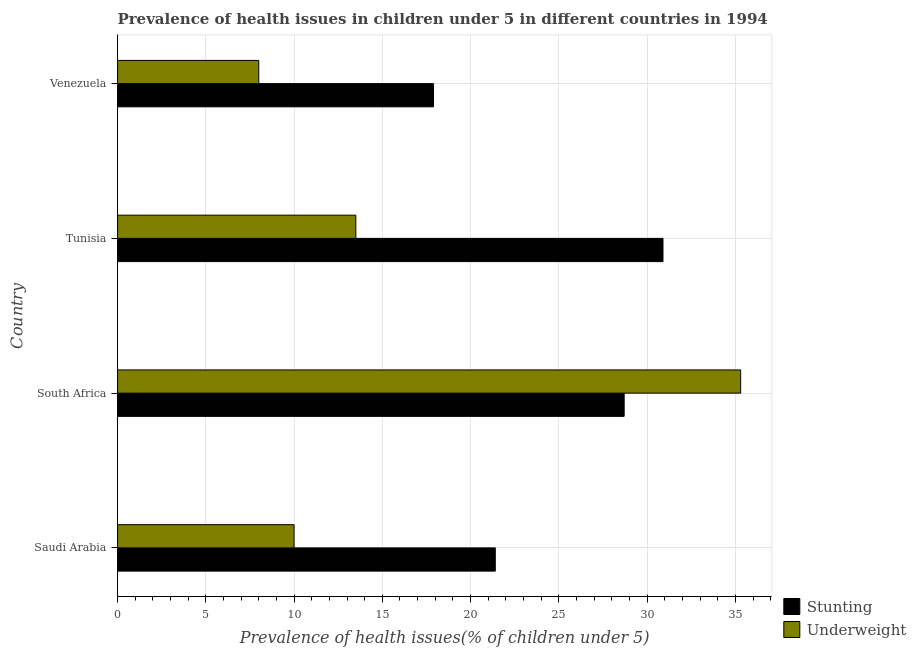How many different coloured bars are there?
Your answer should be compact. 2. Are the number of bars on each tick of the Y-axis equal?
Offer a terse response. Yes. How many bars are there on the 4th tick from the top?
Offer a terse response. 2. How many bars are there on the 4th tick from the bottom?
Your response must be concise. 2. What is the label of the 3rd group of bars from the top?
Keep it short and to the point. South Africa. In how many cases, is the number of bars for a given country not equal to the number of legend labels?
Keep it short and to the point. 0. What is the percentage of underweight children in South Africa?
Your response must be concise. 35.3. Across all countries, what is the maximum percentage of underweight children?
Make the answer very short. 35.3. In which country was the percentage of underweight children maximum?
Give a very brief answer. South Africa. In which country was the percentage of underweight children minimum?
Make the answer very short. Venezuela. What is the total percentage of underweight children in the graph?
Provide a short and direct response. 66.8. What is the difference between the percentage of stunted children in Saudi Arabia and that in Tunisia?
Your answer should be very brief. -9.5. What is the difference between the percentage of stunted children in Venezuela and the percentage of underweight children in Saudi Arabia?
Provide a short and direct response. 7.9. What is the ratio of the percentage of underweight children in South Africa to that in Venezuela?
Provide a short and direct response. 4.41. Is the difference between the percentage of underweight children in South Africa and Tunisia greater than the difference between the percentage of stunted children in South Africa and Tunisia?
Keep it short and to the point. Yes. What is the difference between the highest and the second highest percentage of underweight children?
Offer a very short reply. 21.8. What is the difference between the highest and the lowest percentage of underweight children?
Your answer should be compact. 27.3. In how many countries, is the percentage of stunted children greater than the average percentage of stunted children taken over all countries?
Your response must be concise. 2. Is the sum of the percentage of underweight children in Tunisia and Venezuela greater than the maximum percentage of stunted children across all countries?
Make the answer very short. No. What does the 2nd bar from the top in South Africa represents?
Make the answer very short. Stunting. What does the 2nd bar from the bottom in Venezuela represents?
Your answer should be very brief. Underweight. How many bars are there?
Ensure brevity in your answer.  8. Are all the bars in the graph horizontal?
Offer a terse response. Yes. How many countries are there in the graph?
Your answer should be compact. 4. What is the difference between two consecutive major ticks on the X-axis?
Provide a short and direct response. 5. Does the graph contain any zero values?
Your response must be concise. No. Does the graph contain grids?
Your answer should be very brief. Yes. Where does the legend appear in the graph?
Make the answer very short. Bottom right. How many legend labels are there?
Give a very brief answer. 2. How are the legend labels stacked?
Keep it short and to the point. Vertical. What is the title of the graph?
Ensure brevity in your answer.  Prevalence of health issues in children under 5 in different countries in 1994. Does "Frequency of shipment arrival" appear as one of the legend labels in the graph?
Your answer should be compact. No. What is the label or title of the X-axis?
Your answer should be compact. Prevalence of health issues(% of children under 5). What is the Prevalence of health issues(% of children under 5) in Stunting in Saudi Arabia?
Provide a succinct answer. 21.4. What is the Prevalence of health issues(% of children under 5) of Stunting in South Africa?
Provide a succinct answer. 28.7. What is the Prevalence of health issues(% of children under 5) in Underweight in South Africa?
Your answer should be very brief. 35.3. What is the Prevalence of health issues(% of children under 5) of Stunting in Tunisia?
Your response must be concise. 30.9. What is the Prevalence of health issues(% of children under 5) in Underweight in Tunisia?
Give a very brief answer. 13.5. What is the Prevalence of health issues(% of children under 5) in Stunting in Venezuela?
Keep it short and to the point. 17.9. Across all countries, what is the maximum Prevalence of health issues(% of children under 5) in Stunting?
Provide a succinct answer. 30.9. Across all countries, what is the maximum Prevalence of health issues(% of children under 5) of Underweight?
Provide a succinct answer. 35.3. Across all countries, what is the minimum Prevalence of health issues(% of children under 5) in Stunting?
Your response must be concise. 17.9. Across all countries, what is the minimum Prevalence of health issues(% of children under 5) in Underweight?
Offer a very short reply. 8. What is the total Prevalence of health issues(% of children under 5) in Stunting in the graph?
Your response must be concise. 98.9. What is the total Prevalence of health issues(% of children under 5) of Underweight in the graph?
Keep it short and to the point. 66.8. What is the difference between the Prevalence of health issues(% of children under 5) in Stunting in Saudi Arabia and that in South Africa?
Your response must be concise. -7.3. What is the difference between the Prevalence of health issues(% of children under 5) in Underweight in Saudi Arabia and that in South Africa?
Provide a short and direct response. -25.3. What is the difference between the Prevalence of health issues(% of children under 5) of Stunting in Saudi Arabia and that in Venezuela?
Offer a terse response. 3.5. What is the difference between the Prevalence of health issues(% of children under 5) of Stunting in South Africa and that in Tunisia?
Offer a terse response. -2.2. What is the difference between the Prevalence of health issues(% of children under 5) of Underweight in South Africa and that in Tunisia?
Give a very brief answer. 21.8. What is the difference between the Prevalence of health issues(% of children under 5) in Underweight in South Africa and that in Venezuela?
Ensure brevity in your answer.  27.3. What is the difference between the Prevalence of health issues(% of children under 5) in Stunting in Tunisia and that in Venezuela?
Keep it short and to the point. 13. What is the difference between the Prevalence of health issues(% of children under 5) in Underweight in Tunisia and that in Venezuela?
Your answer should be compact. 5.5. What is the difference between the Prevalence of health issues(% of children under 5) in Stunting in Saudi Arabia and the Prevalence of health issues(% of children under 5) in Underweight in South Africa?
Ensure brevity in your answer.  -13.9. What is the difference between the Prevalence of health issues(% of children under 5) of Stunting in Saudi Arabia and the Prevalence of health issues(% of children under 5) of Underweight in Venezuela?
Offer a terse response. 13.4. What is the difference between the Prevalence of health issues(% of children under 5) in Stunting in South Africa and the Prevalence of health issues(% of children under 5) in Underweight in Tunisia?
Your answer should be compact. 15.2. What is the difference between the Prevalence of health issues(% of children under 5) of Stunting in South Africa and the Prevalence of health issues(% of children under 5) of Underweight in Venezuela?
Ensure brevity in your answer.  20.7. What is the difference between the Prevalence of health issues(% of children under 5) in Stunting in Tunisia and the Prevalence of health issues(% of children under 5) in Underweight in Venezuela?
Provide a short and direct response. 22.9. What is the average Prevalence of health issues(% of children under 5) of Stunting per country?
Give a very brief answer. 24.73. What is the average Prevalence of health issues(% of children under 5) in Underweight per country?
Your answer should be very brief. 16.7. What is the difference between the Prevalence of health issues(% of children under 5) of Stunting and Prevalence of health issues(% of children under 5) of Underweight in Tunisia?
Your answer should be very brief. 17.4. What is the difference between the Prevalence of health issues(% of children under 5) in Stunting and Prevalence of health issues(% of children under 5) in Underweight in Venezuela?
Offer a very short reply. 9.9. What is the ratio of the Prevalence of health issues(% of children under 5) in Stunting in Saudi Arabia to that in South Africa?
Make the answer very short. 0.75. What is the ratio of the Prevalence of health issues(% of children under 5) in Underweight in Saudi Arabia to that in South Africa?
Ensure brevity in your answer.  0.28. What is the ratio of the Prevalence of health issues(% of children under 5) in Stunting in Saudi Arabia to that in Tunisia?
Offer a very short reply. 0.69. What is the ratio of the Prevalence of health issues(% of children under 5) of Underweight in Saudi Arabia to that in Tunisia?
Offer a terse response. 0.74. What is the ratio of the Prevalence of health issues(% of children under 5) of Stunting in Saudi Arabia to that in Venezuela?
Keep it short and to the point. 1.2. What is the ratio of the Prevalence of health issues(% of children under 5) of Stunting in South Africa to that in Tunisia?
Make the answer very short. 0.93. What is the ratio of the Prevalence of health issues(% of children under 5) in Underweight in South Africa to that in Tunisia?
Ensure brevity in your answer.  2.61. What is the ratio of the Prevalence of health issues(% of children under 5) of Stunting in South Africa to that in Venezuela?
Your response must be concise. 1.6. What is the ratio of the Prevalence of health issues(% of children under 5) of Underweight in South Africa to that in Venezuela?
Your answer should be very brief. 4.41. What is the ratio of the Prevalence of health issues(% of children under 5) of Stunting in Tunisia to that in Venezuela?
Provide a short and direct response. 1.73. What is the ratio of the Prevalence of health issues(% of children under 5) of Underweight in Tunisia to that in Venezuela?
Offer a terse response. 1.69. What is the difference between the highest and the second highest Prevalence of health issues(% of children under 5) of Underweight?
Give a very brief answer. 21.8. What is the difference between the highest and the lowest Prevalence of health issues(% of children under 5) of Stunting?
Offer a terse response. 13. What is the difference between the highest and the lowest Prevalence of health issues(% of children under 5) in Underweight?
Offer a terse response. 27.3. 